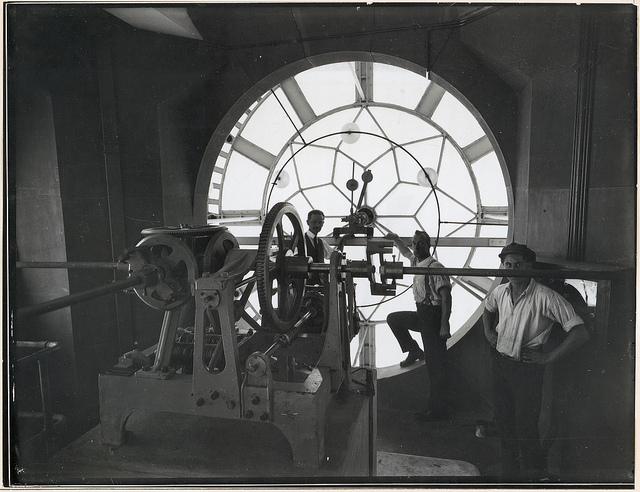What shape is the window?
Short answer required. Circle. What is this room?
Answer briefly. Clock tower. Where is the furthest man standing?
Write a very short answer. Clock face. 